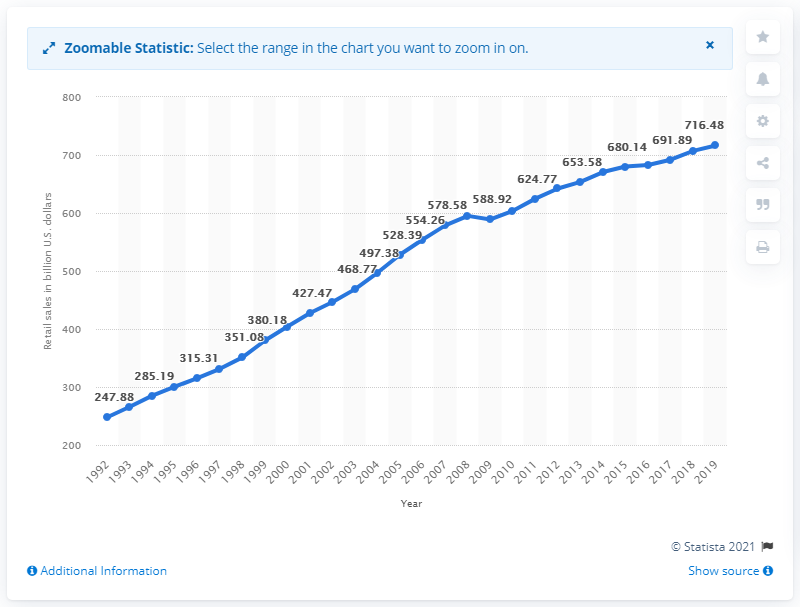Highlight a few significant elements in this photo. The sales of general merchandise stores began to increase in 1992. In the United States, the sales of general merchandise stores in 2019 were approximately 716.48 billion dollars. 